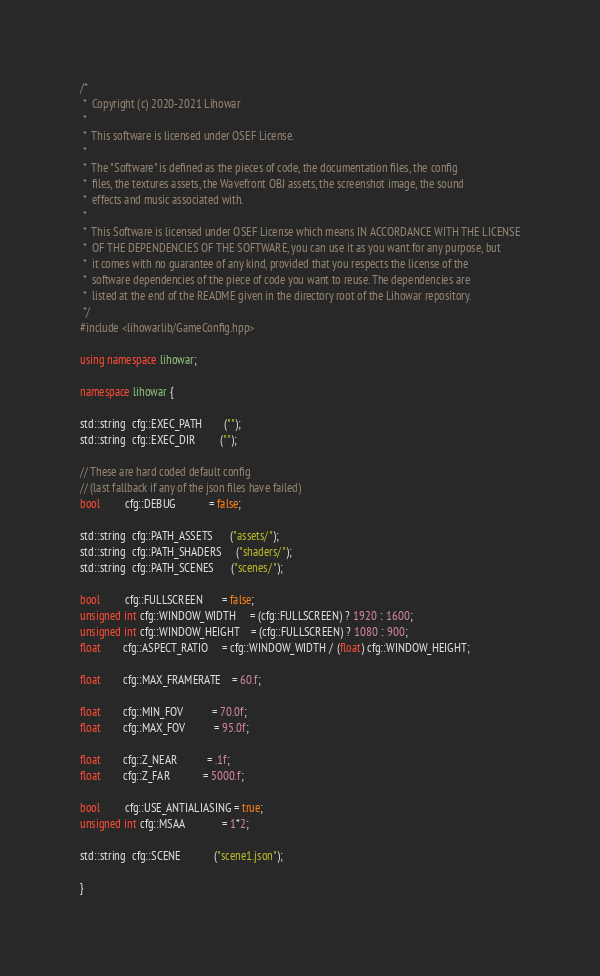<code> <loc_0><loc_0><loc_500><loc_500><_C++_>/*
 *  Copyright (c) 2020-2021 Lihowar
 *
 *  This software is licensed under OSEF License.
 *
 *  The "Software" is defined as the pieces of code, the documentation files, the config
 *  files, the textures assets, the Wavefront OBJ assets, the screenshot image, the sound
 *  effects and music associated with.
 *
 *  This Software is licensed under OSEF License which means IN ACCORDANCE WITH THE LICENSE
 *  OF THE DEPENDENCIES OF THE SOFTWARE, you can use it as you want for any purpose, but
 *  it comes with no guarantee of any kind, provided that you respects the license of the
 *  software dependencies of the piece of code you want to reuse. The dependencies are
 *  listed at the end of the README given in the directory root of the Lihowar repository.
 */
#include <lihowarlib/GameConfig.hpp>

using namespace lihowar;

namespace lihowar {

std::string  cfg::EXEC_PATH        ("");
std::string  cfg::EXEC_DIR         ("");

// These are hard coded default config
// (last fallback if any of the json files have failed)
bool         cfg::DEBUG            = false;

std::string  cfg::PATH_ASSETS      ("assets/");
std::string  cfg::PATH_SHADERS     ("shaders/");
std::string  cfg::PATH_SCENES      ("scenes/");

bool         cfg::FULLSCREEN       = false;
unsigned int cfg::WINDOW_WIDTH     = (cfg::FULLSCREEN) ? 1920 : 1600;
unsigned int cfg::WINDOW_HEIGHT    = (cfg::FULLSCREEN) ? 1080 : 900;
float        cfg::ASPECT_RATIO     = cfg::WINDOW_WIDTH / (float) cfg::WINDOW_HEIGHT;

float        cfg::MAX_FRAMERATE    = 60.f;

float        cfg::MIN_FOV          = 70.0f;
float        cfg::MAX_FOV          = 95.0f;

float        cfg::Z_NEAR           = .1f;
float        cfg::Z_FAR            = 5000.f;

bool         cfg::USE_ANTIALIASING = true;
unsigned int cfg::MSAA             = 1*2;

std::string  cfg::SCENE            ("scene1.json");

}
</code> 